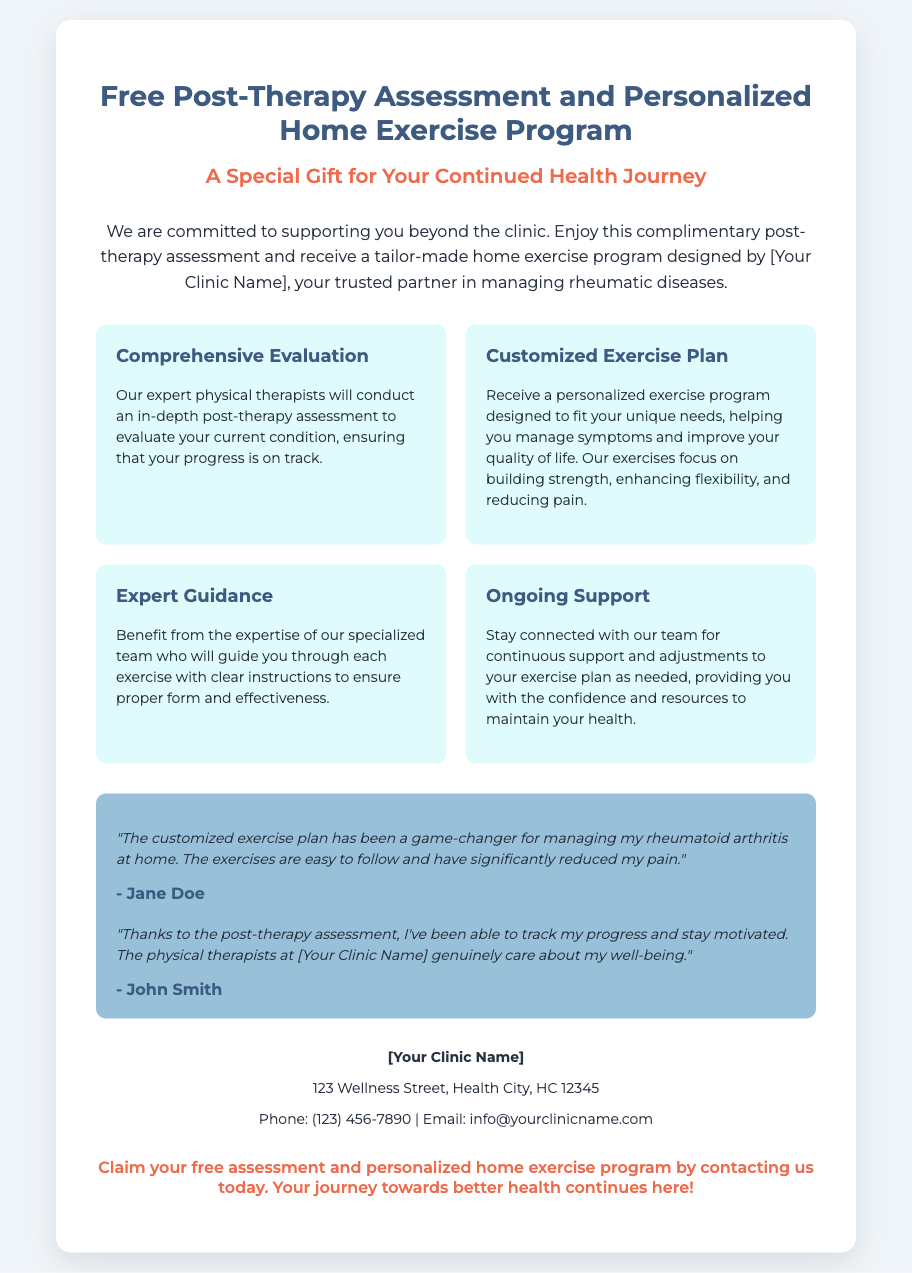What is the title of the voucher? The title of the voucher is located at the top of the document, which states the purpose of the voucher.
Answer: Free Post-Therapy Assessment and Personalized Home Exercise Program What type of program is included with the voucher? The document explicitly mentions the program that the voucher offers.
Answer: Personalized Home Exercise Program Who will conduct the post-therapy assessment? The document specifies the professionals responsible for the assessment.
Answer: Expert physical therapists What is one benefit of the customized exercise plan? The document lists multiple benefits of the exercise plan that is provided.
Answer: Building strength What is the background color of the voucher? The document describes the overall design and aesthetic used, including colors.
Answer: White What do patients receive for free according to the voucher? The document indicates the specific offer available with the voucher.
Answer: Post-therapy assessment What feedback did Jane Doe provide? The document includes testimonials from clients describing their experiences.
Answer: A game-changer for managing my rheumatoid arthritis at home How many benefits are listed in the document? The document organizes benefits into distinct sections.
Answer: Four 